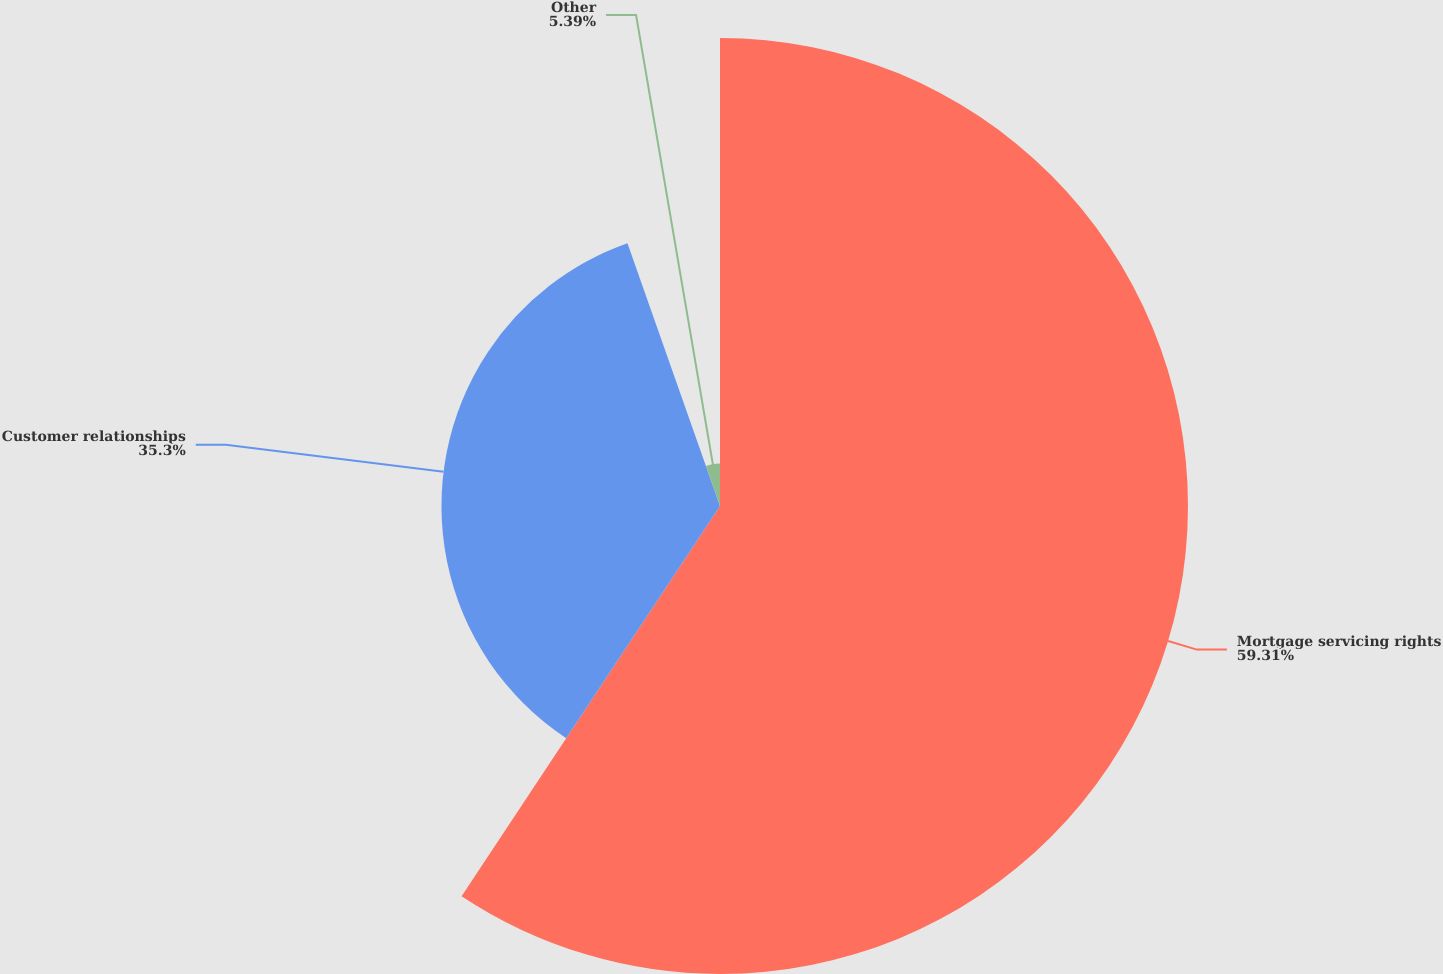Convert chart to OTSL. <chart><loc_0><loc_0><loc_500><loc_500><pie_chart><fcel>Mortgage servicing rights<fcel>Customer relationships<fcel>Other<nl><fcel>59.31%<fcel>35.3%<fcel>5.39%<nl></chart> 